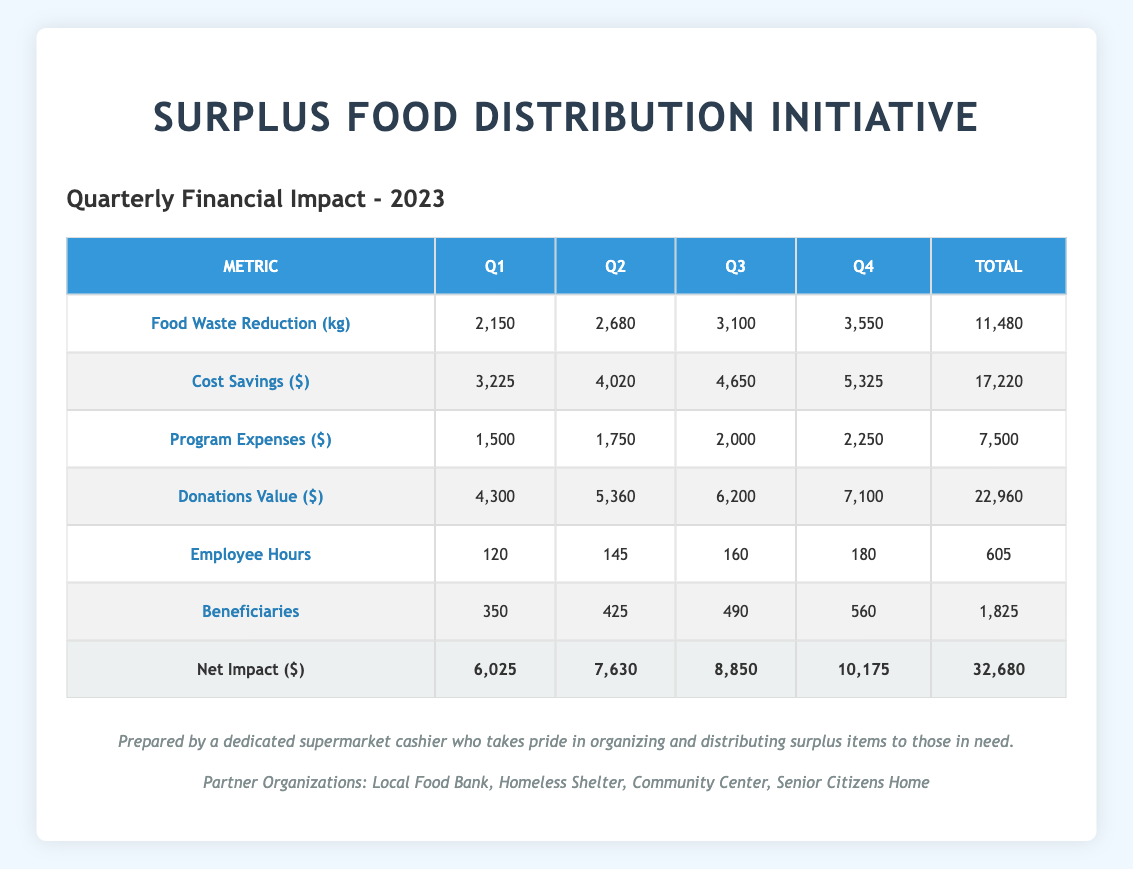What was the total food waste reduced in Q1 2023? From the table, the food waste reduction in Q1 2023 is explicitly listed as 2,150 kg.
Answer: 2,150 kg How much did the program expenses increase from Q1 to Q4? The program expenses in Q1 are 1,500 and in Q4 are 2,250. To find the increase, subtract Q1 expenses from Q4 expenses: 2,250 - 1,500 = 750.
Answer: 750 What is the total cost savings for the entire year? To find the total cost savings, sum the cost savings from all quarters: 3,225 + 4,020 + 4,650 + 5,325 = 17,220.
Answer: 17,220 How many employees contributed over the year in total hours? The total employee hours are found by adding the hours for each quarter: 120 + 145 + 160 + 180 = 605.
Answer: 605 Did the number of beneficiaries increase every quarter? By examining the beneficiaries per quarter: Q1 has 350, Q2 has 425, Q3 has 490, and Q4 has 560. Each quarter shows an increase in beneficiaries.
Answer: Yes What was the average value of donations per quarter? The total donation value for the year is 22,960. Dividing this by the 4 quarters gives an average of 22,960 / 4 = 5,740.
Answer: 5,740 Which quarter had the highest food waste reduction, and how much was it? The food waste reduction increased each quarter, with Q4 having the highest at 3,550 kg, as seen in the food waste reduction row.
Answer: Q4, 3,550 kg What was the net impact in Q2 compared to Q1? The net impact for Q1 is 6,025 and for Q2 is 7,630. To find the difference: 7,630 - 6,025 = 1,605, showing an increase in Q2.
Answer: Increased by 1,605 How many beneficiaries were served in total over the year? To find the total number of beneficiaries, add the numbers from each quarter: 350 + 425 + 490 + 560 = 1,825.
Answer: 1,825 